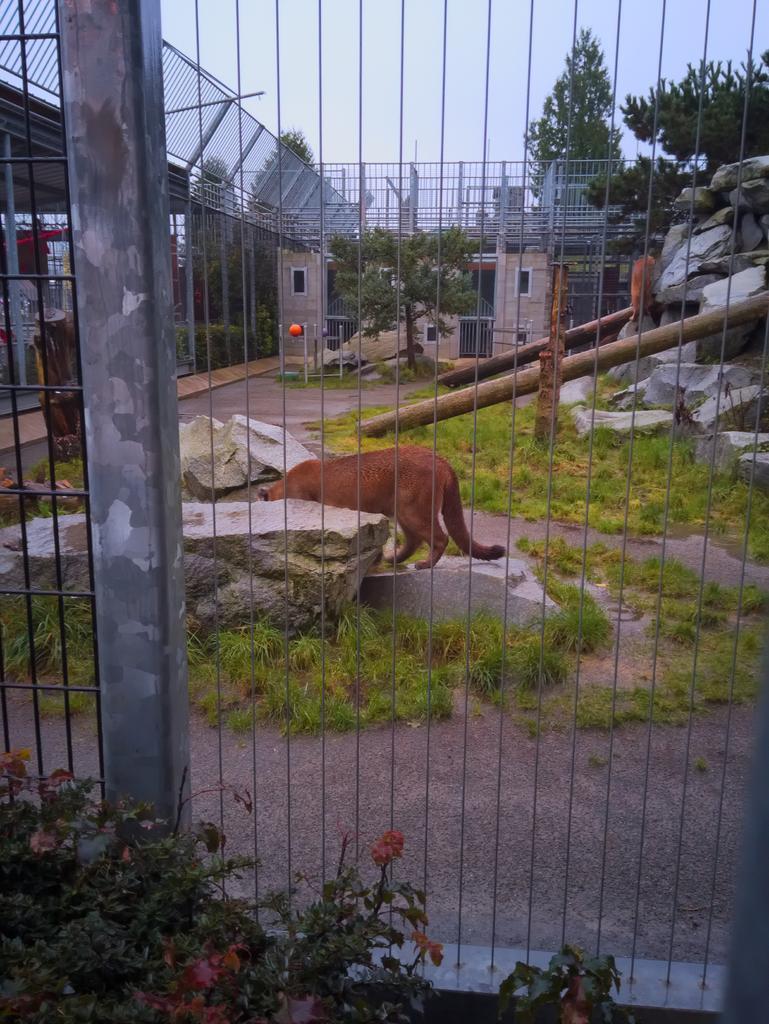Describe this image in one or two sentences. This image is clicked outside. There are trees at the top. There is grass at the bottom. There is a fence in the front. There is a dog in the middle. There is building on the left side. 